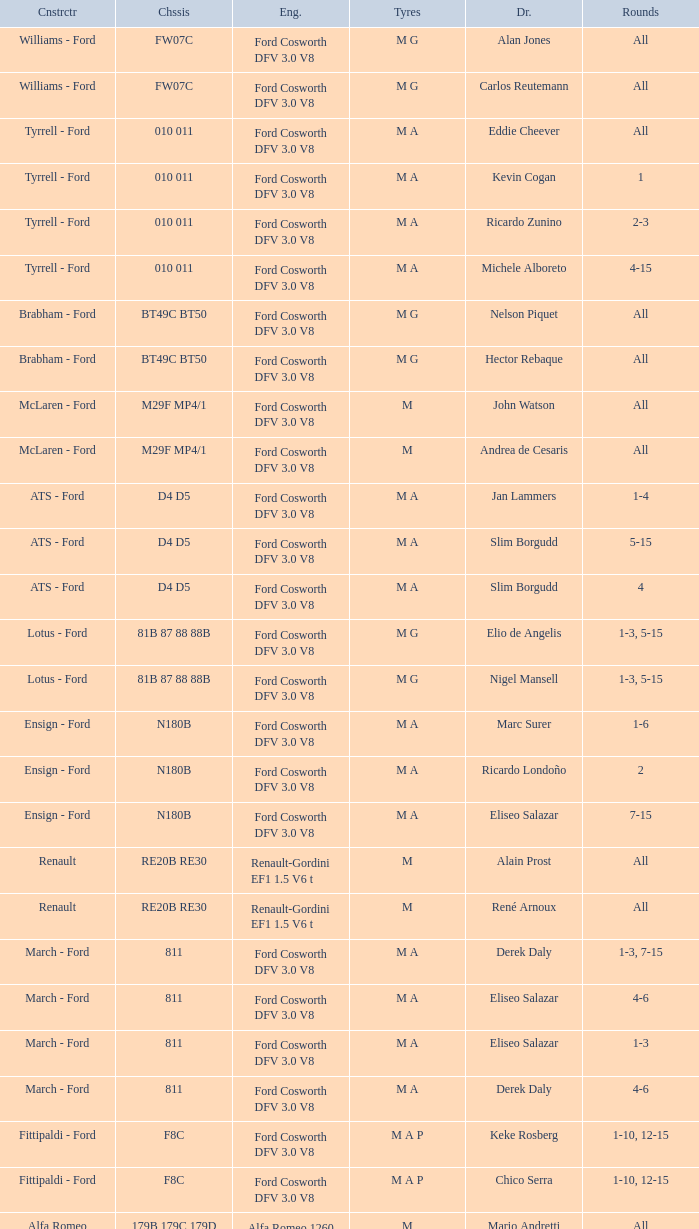Who constructed the car that Derek Warwick raced in with a TG181 chassis? Toleman - Hart. 